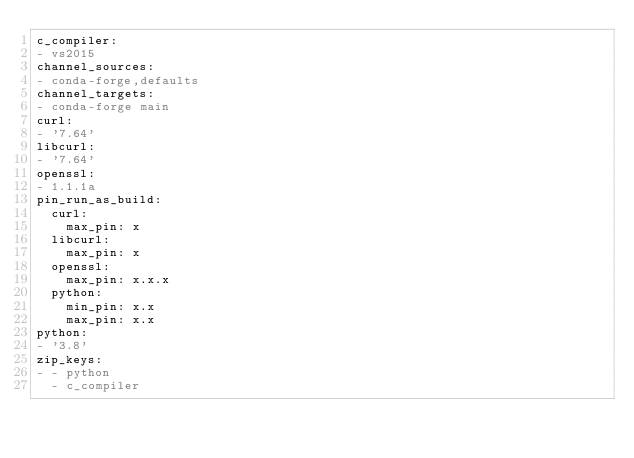<code> <loc_0><loc_0><loc_500><loc_500><_YAML_>c_compiler:
- vs2015
channel_sources:
- conda-forge,defaults
channel_targets:
- conda-forge main
curl:
- '7.64'
libcurl:
- '7.64'
openssl:
- 1.1.1a
pin_run_as_build:
  curl:
    max_pin: x
  libcurl:
    max_pin: x
  openssl:
    max_pin: x.x.x
  python:
    min_pin: x.x
    max_pin: x.x
python:
- '3.8'
zip_keys:
- - python
  - c_compiler
</code> 